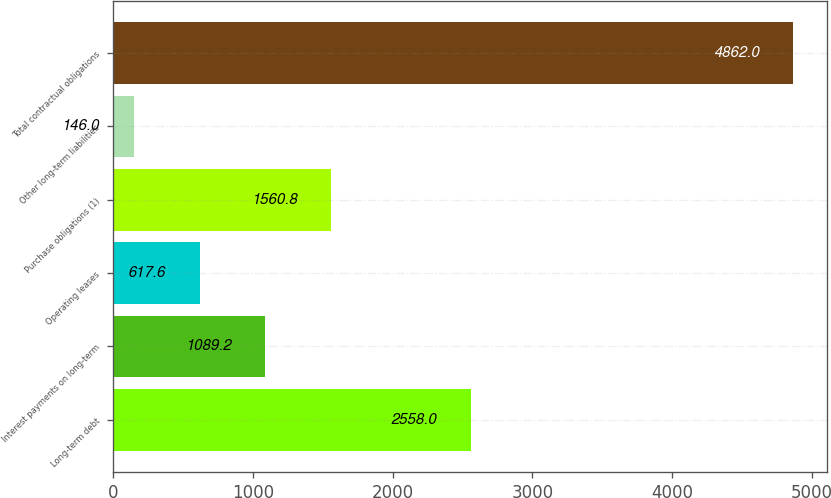Convert chart to OTSL. <chart><loc_0><loc_0><loc_500><loc_500><bar_chart><fcel>Long-term debt<fcel>Interest payments on long-term<fcel>Operating leases<fcel>Purchase obligations (1)<fcel>Other long-term liabilities<fcel>Total contractual obligations<nl><fcel>2558<fcel>1089.2<fcel>617.6<fcel>1560.8<fcel>146<fcel>4862<nl></chart> 